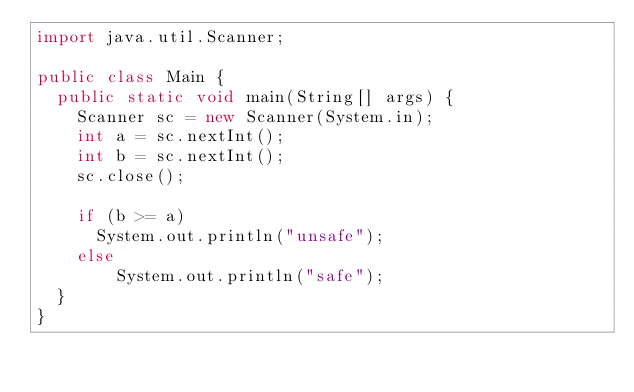<code> <loc_0><loc_0><loc_500><loc_500><_Java_>import java.util.Scanner;

public class Main {
  public static void main(String[] args) {
    Scanner sc = new Scanner(System.in);
    int a = sc.nextInt();
    int b = sc.nextInt();
    sc.close();

    if (b >= a)
      System.out.println("unsafe");
    else
		System.out.println("safe");
  }
}</code> 